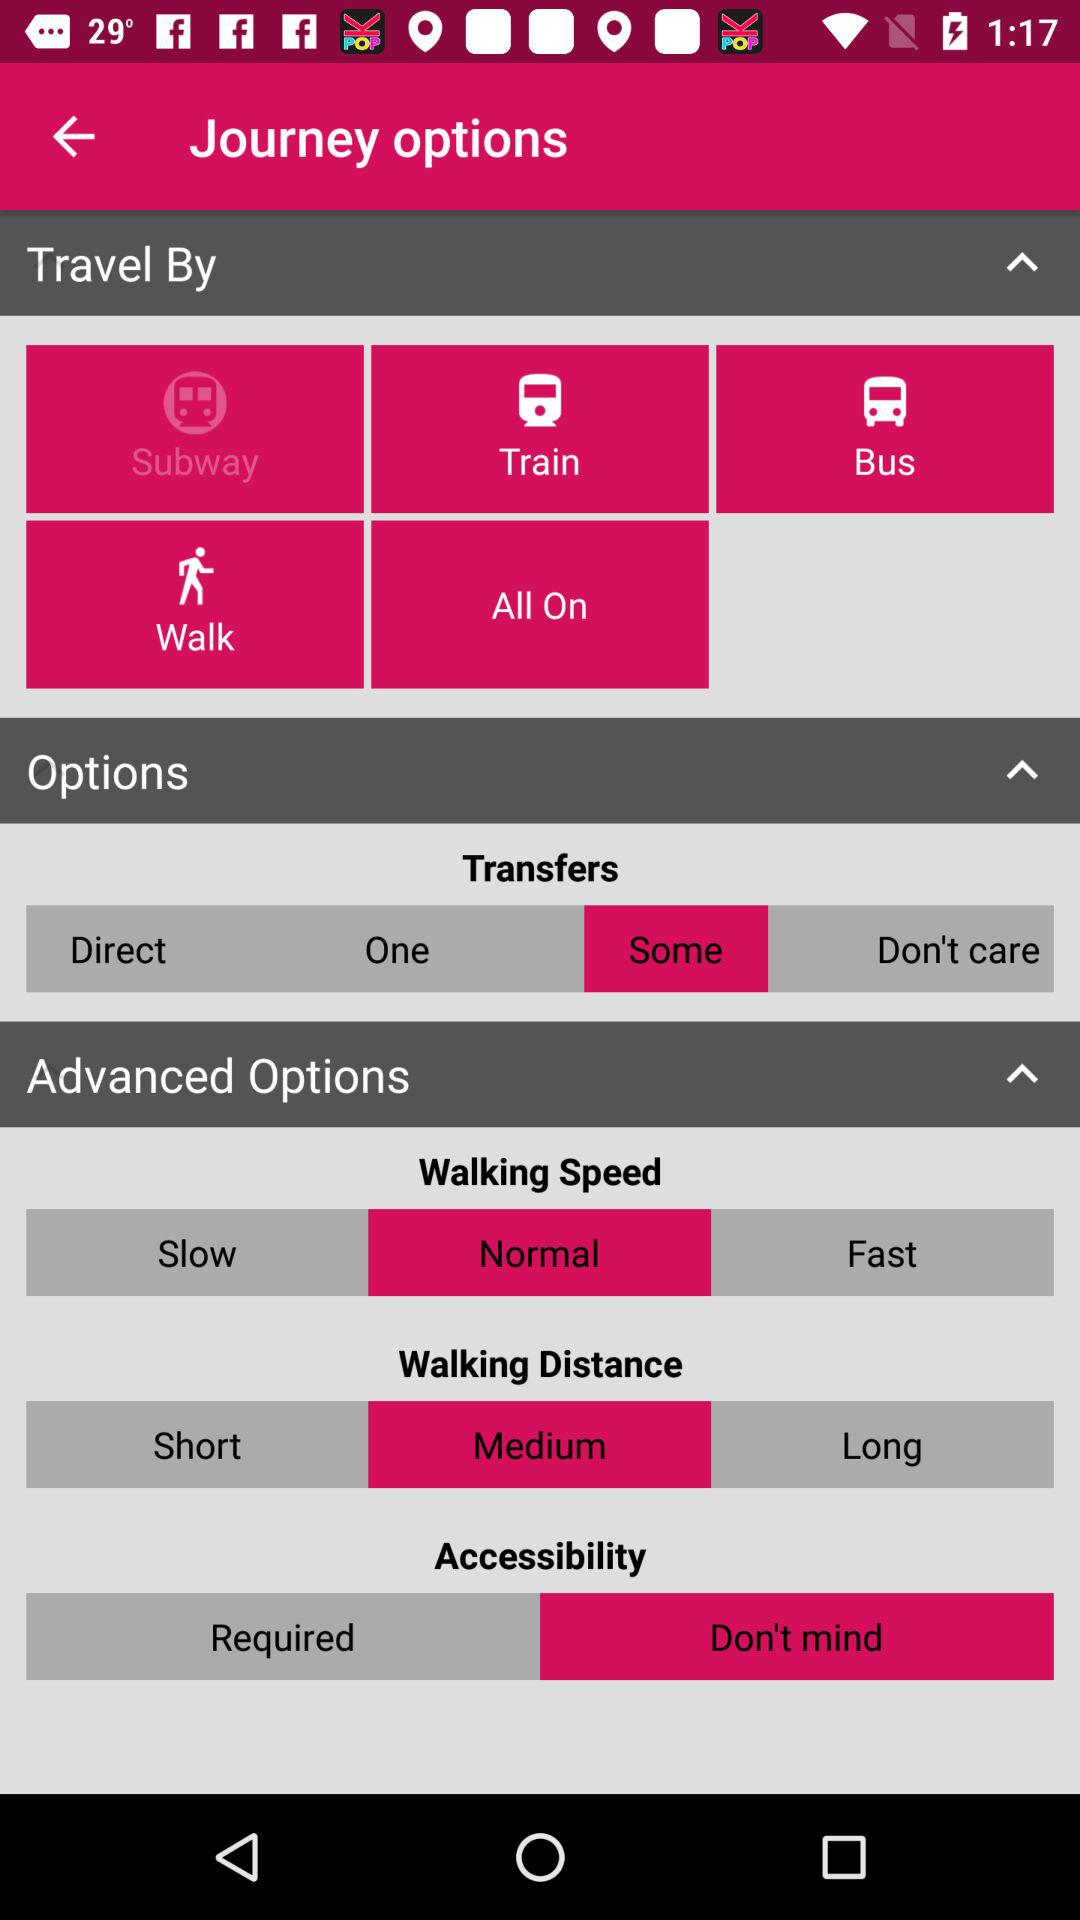What is the status of bus speed?
When the provided information is insufficient, respond with <no answer>. <no answer> 